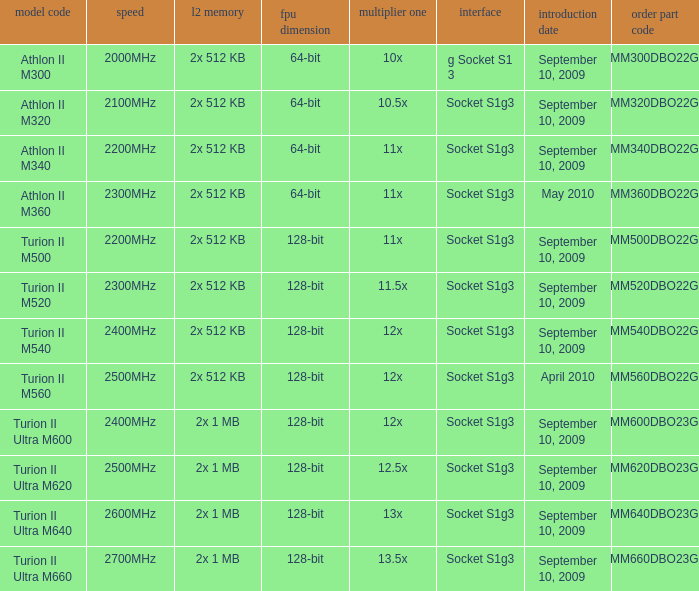What is the release date of the 2x 512 kb L2 cache with a 11x multi 1, and a FPU width of 128-bit? September 10, 2009. 